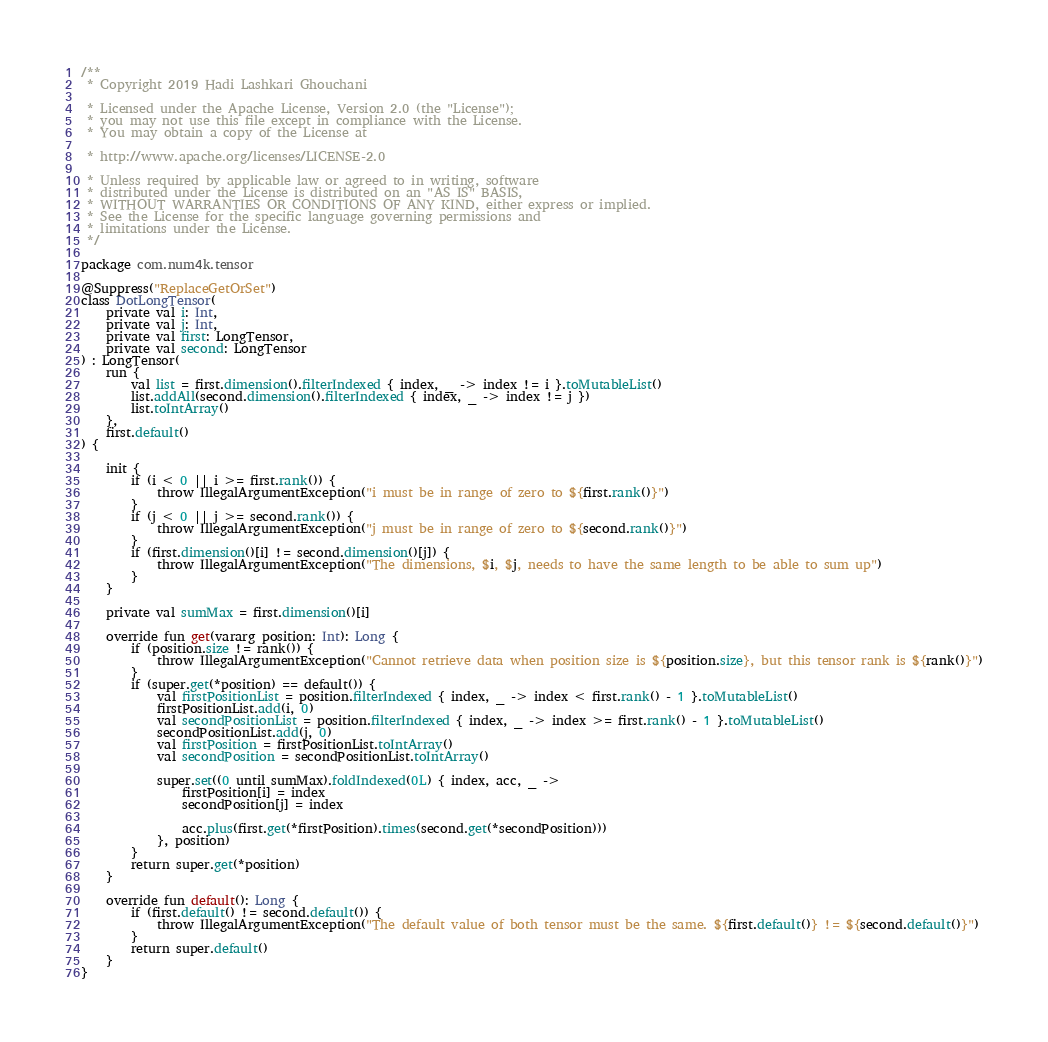<code> <loc_0><loc_0><loc_500><loc_500><_Kotlin_>/**
 * Copyright 2019 Hadi Lashkari Ghouchani

 * Licensed under the Apache License, Version 2.0 (the "License");
 * you may not use this file except in compliance with the License.
 * You may obtain a copy of the License at

 * http://www.apache.org/licenses/LICENSE-2.0

 * Unless required by applicable law or agreed to in writing, software
 * distributed under the License is distributed on an "AS IS" BASIS,
 * WITHOUT WARRANTIES OR CONDITIONS OF ANY KIND, either express or implied.
 * See the License for the specific language governing permissions and
 * limitations under the License.
 */

package com.num4k.tensor

@Suppress("ReplaceGetOrSet")
class DotLongTensor(
    private val i: Int,
    private val j: Int,
    private val first: LongTensor,
    private val second: LongTensor
) : LongTensor(
    run {
        val list = first.dimension().filterIndexed { index, _ -> index != i }.toMutableList()
        list.addAll(second.dimension().filterIndexed { index, _ -> index != j })
        list.toIntArray()
    },
    first.default()
) {

    init {
        if (i < 0 || i >= first.rank()) {
            throw IllegalArgumentException("i must be in range of zero to ${first.rank()}")
        }
        if (j < 0 || j >= second.rank()) {
            throw IllegalArgumentException("j must be in range of zero to ${second.rank()}")
        }
        if (first.dimension()[i] != second.dimension()[j]) {
            throw IllegalArgumentException("The dimensions, $i, $j, needs to have the same length to be able to sum up")
        }
    }

    private val sumMax = first.dimension()[i]

    override fun get(vararg position: Int): Long {
        if (position.size != rank()) {
            throw IllegalArgumentException("Cannot retrieve data when position size is ${position.size}, but this tensor rank is ${rank()}")
        }
        if (super.get(*position) == default()) {
            val firstPositionList = position.filterIndexed { index, _ -> index < first.rank() - 1 }.toMutableList()
            firstPositionList.add(i, 0)
            val secondPositionList = position.filterIndexed { index, _ -> index >= first.rank() - 1 }.toMutableList()
            secondPositionList.add(j, 0)
            val firstPosition = firstPositionList.toIntArray()
            val secondPosition = secondPositionList.toIntArray()

            super.set((0 until sumMax).foldIndexed(0L) { index, acc, _ ->
                firstPosition[i] = index
                secondPosition[j] = index

                acc.plus(first.get(*firstPosition).times(second.get(*secondPosition)))
            }, position)
        }
        return super.get(*position)
    }

    override fun default(): Long {
        if (first.default() != second.default()) {
            throw IllegalArgumentException("The default value of both tensor must be the same. ${first.default()} != ${second.default()}")
        }
        return super.default()
    }
}

</code> 